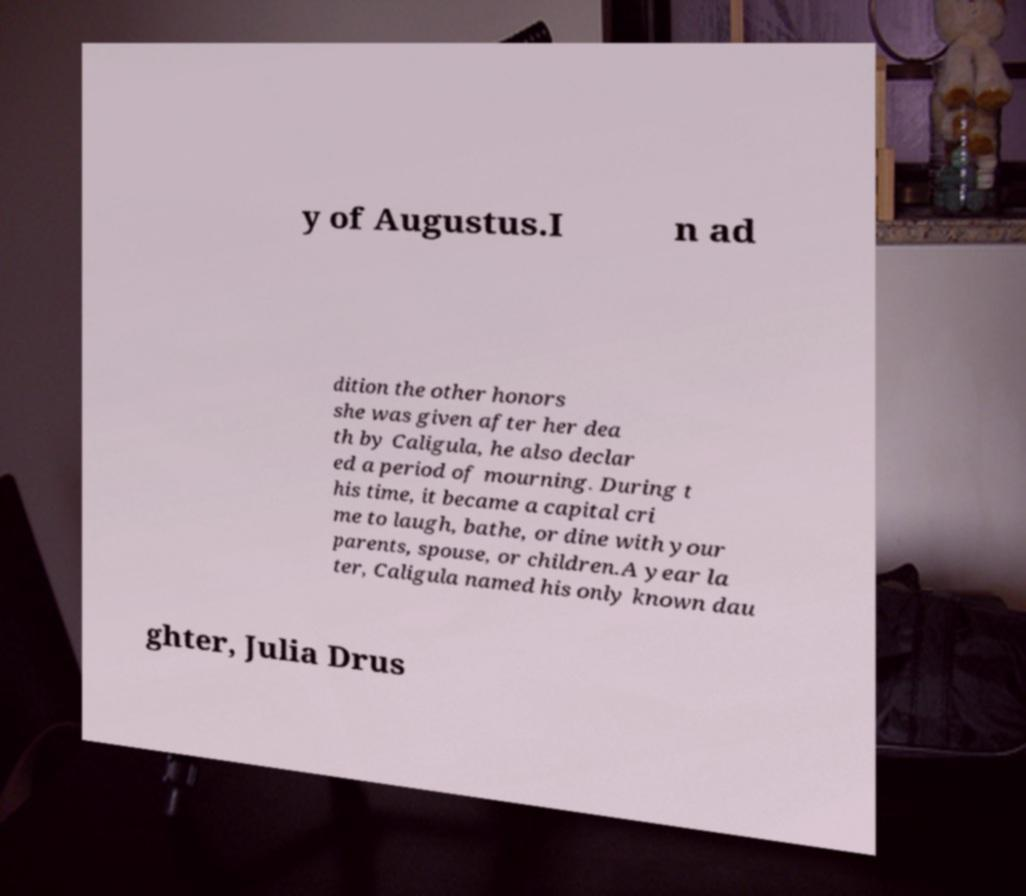What messages or text are displayed in this image? I need them in a readable, typed format. y of Augustus.I n ad dition the other honors she was given after her dea th by Caligula, he also declar ed a period of mourning. During t his time, it became a capital cri me to laugh, bathe, or dine with your parents, spouse, or children.A year la ter, Caligula named his only known dau ghter, Julia Drus 